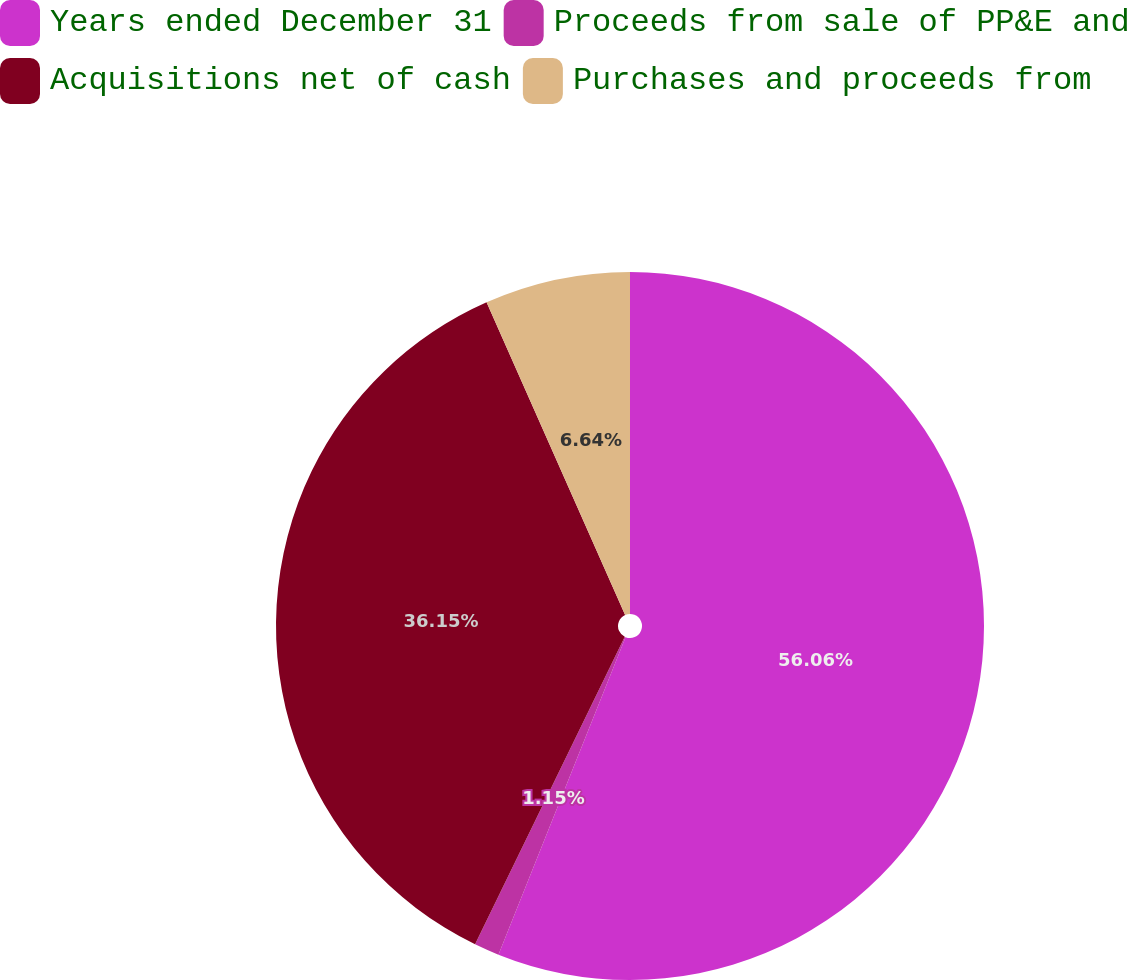Convert chart to OTSL. <chart><loc_0><loc_0><loc_500><loc_500><pie_chart><fcel>Years ended December 31<fcel>Proceeds from sale of PP&E and<fcel>Acquisitions net of cash<fcel>Purchases and proceeds from<nl><fcel>56.06%<fcel>1.15%<fcel>36.15%<fcel>6.64%<nl></chart> 